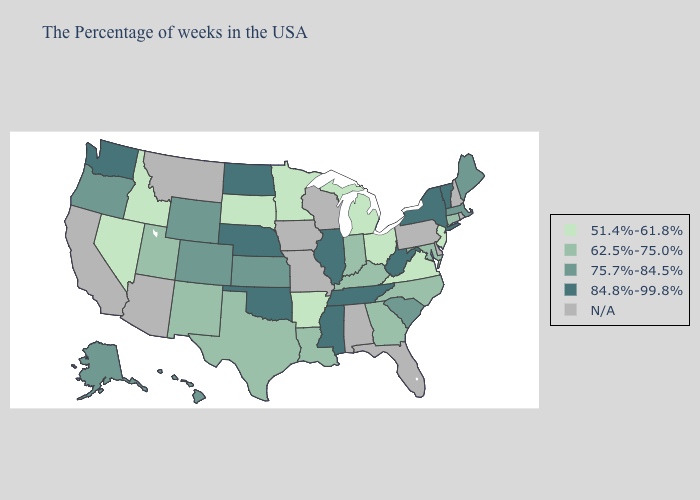Is the legend a continuous bar?
Answer briefly. No. Does Oregon have the highest value in the USA?
Short answer required. No. Name the states that have a value in the range N/A?
Concise answer only. Rhode Island, New Hampshire, Delaware, Pennsylvania, Florida, Alabama, Wisconsin, Missouri, Iowa, Montana, Arizona, California. What is the lowest value in the Northeast?
Keep it brief. 51.4%-61.8%. Does Washington have the lowest value in the USA?
Short answer required. No. What is the highest value in states that border Indiana?
Answer briefly. 84.8%-99.8%. Does the map have missing data?
Concise answer only. Yes. Which states hav the highest value in the West?
Be succinct. Washington. Does Arkansas have the lowest value in the South?
Short answer required. Yes. What is the lowest value in states that border West Virginia?
Concise answer only. 51.4%-61.8%. What is the value of Tennessee?
Answer briefly. 84.8%-99.8%. Among the states that border West Virginia , which have the lowest value?
Keep it brief. Virginia, Ohio. Is the legend a continuous bar?
Quick response, please. No. 